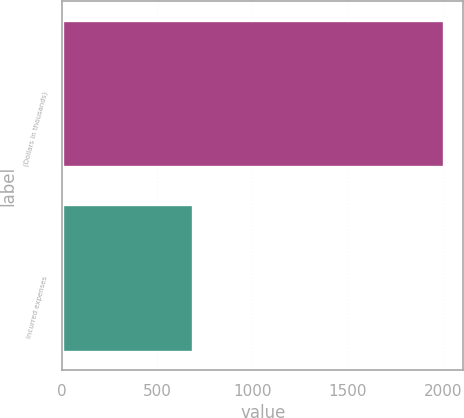<chart> <loc_0><loc_0><loc_500><loc_500><bar_chart><fcel>(Dollars in thousands)<fcel>Incurred expenses<nl><fcel>2008<fcel>687<nl></chart> 